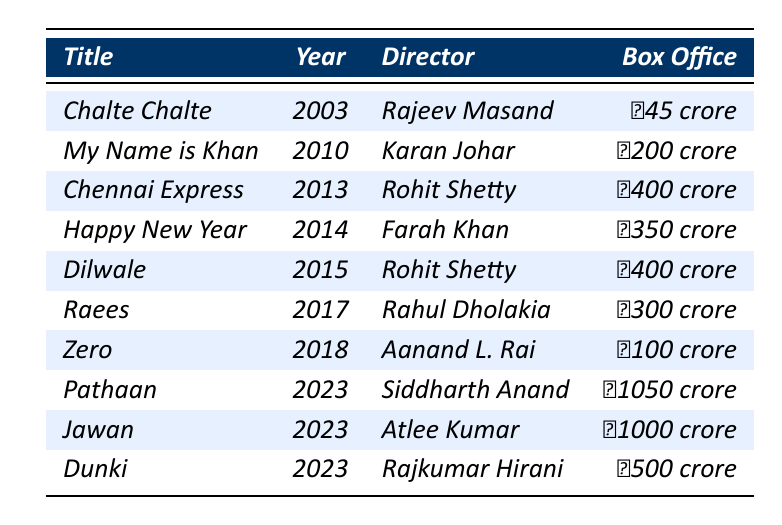What is the highest box office collection among Shah Rukh Khan's movies listed? The highest box office collection is ₹1050 crore from the movie "Pathaan." This value is directly taken from the "Box Office" column of the table.
Answer: ₹1050 crore Which movie directed by Rohit Shetty had the highest earnings? The movies directed by Rohit Shetty are "Chennai Express" and "Dilwale," both with collections of ₹400 crore. Since they are tied, either can be considered the highest.
Answer: Chennai Express or Dilwale What is the total box office collection of all the films released in 2023? The films released in 2023 are "Pathaan" (₹1050 crore), "Jawan" (₹1000 crore), and "Dunki" (₹500 crore). Summing these values gets us: 1050 + 1000 + 500 = ₹2550 crore.
Answer: ₹2550 crore Did Shah Rukh Khan's film "Zero" make more than ₹200 crore at the box office? "Zero" had a box office collection of ₹100 crore, which is less than ₹200 crore. This fact can be directly checked against the box office collection listed for "Zero."
Answer: No What is the average box office collection of the movies released between 2010 and 2018? The movies from 2010 to 2018 are "My Name is Khan" (₹200 crore), "Chennai Express" (₹400 crore), "Happy New Year" (₹350 crore), "Dilwale" (₹400 crore), "Raees" (₹300 crore), and "Zero" (₹100 crore). Summing these collections gives us 200 + 400 + 350 + 400 + 300 + 100 = ₹1750 crore. There are 6 movies, so the average is 1750/6 ≈ ₹291.67 crore.
Answer: ₹291.67 crore Which year had the highest revenue from a single movie? The year 2023 saw the release of "Pathaan" with a box office collection of ₹1050 crore, the highest from any single movie in the table. This can be verified by comparing the individual movie revenues across the years.
Answer: 2023 What percentage of the total box office collection of all movies is contributed by "Happy New Year"? The total box office collection of all movies is ₹4000 crore (calculated by summing all values). "Happy New Year" collected ₹350 crore. The percentage contribution is (350/4000)*100 = 8.75%.
Answer: 8.75% Is there a movie directed by Farah Khan in this table? Yes, "Happy New Year" directed by Farah Khan is listed in the table. This information can be confirmed by checking the "Director" column for that specific title.
Answer: Yes How many movies had a box office collection of over ₹300 crore? The movies over ₹300 crore are "My Name is Khan" (₹200 crore does not count), "Chennai Express" (₹400 crore), "Happy New Year" (₹350 crore), "Dilwale" (₹400 crore), "Raees" (₹300 crore), "Pathaan" (₹1050 crore), and "Jawan" (₹1000 crore). Therefore, there are 5 movies fitting this criterion: "Chennai Express," "Happy New Year," "Dilwale," "Pathaan," and "Jawan."
Answer: 5 What was the box office collection of Shah Rukh Khan’s first film after 2010, and how does it compare to his last film in the same period? The first film after 2010 is "Chennai Express," which collected ₹400 crore, and the last film in this period is "Raees," which collected ₹300 crore. "Chennai Express" exceeded "Raees" by ₹100 crore.
Answer: ₹400 crore, more by ₹100 crore 